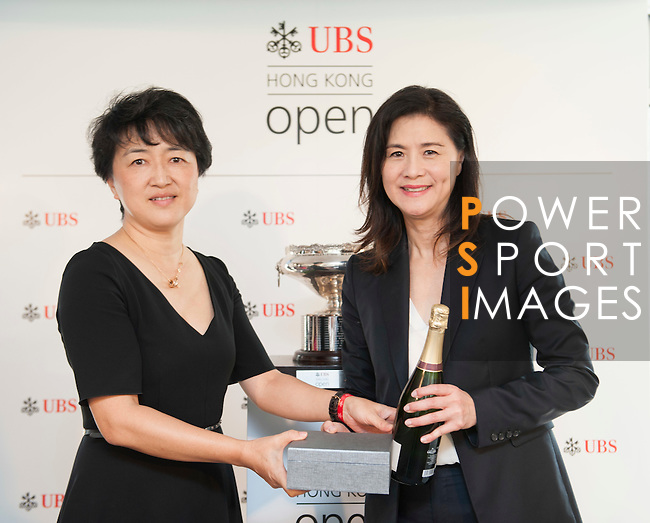What can we infer about the event or the roles of the women from this image? Although specifics cannot be inferred with certainty, the presence of a trophy, a presentation box, and champagne typically are associated with award ceremonies or celebratory events. It's plausible that the women have significant roles within the event, possibly as presenters, award recipients, or organizers. However, without additional context, we can only speculate on their exact roles. 